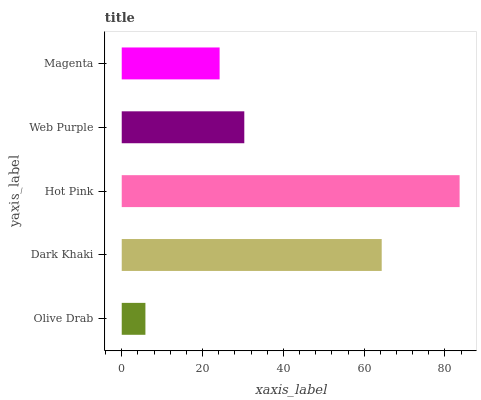Is Olive Drab the minimum?
Answer yes or no. Yes. Is Hot Pink the maximum?
Answer yes or no. Yes. Is Dark Khaki the minimum?
Answer yes or no. No. Is Dark Khaki the maximum?
Answer yes or no. No. Is Dark Khaki greater than Olive Drab?
Answer yes or no. Yes. Is Olive Drab less than Dark Khaki?
Answer yes or no. Yes. Is Olive Drab greater than Dark Khaki?
Answer yes or no. No. Is Dark Khaki less than Olive Drab?
Answer yes or no. No. Is Web Purple the high median?
Answer yes or no. Yes. Is Web Purple the low median?
Answer yes or no. Yes. Is Hot Pink the high median?
Answer yes or no. No. Is Olive Drab the low median?
Answer yes or no. No. 